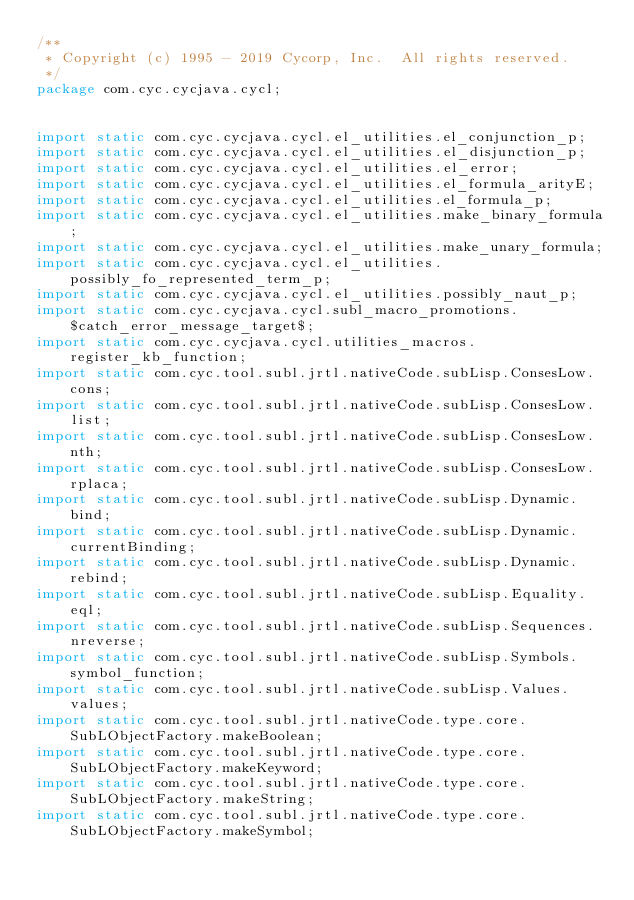<code> <loc_0><loc_0><loc_500><loc_500><_Java_>/**
 * Copyright (c) 1995 - 2019 Cycorp, Inc.  All rights reserved.
 */
package com.cyc.cycjava.cycl;


import static com.cyc.cycjava.cycl.el_utilities.el_conjunction_p;
import static com.cyc.cycjava.cycl.el_utilities.el_disjunction_p;
import static com.cyc.cycjava.cycl.el_utilities.el_error;
import static com.cyc.cycjava.cycl.el_utilities.el_formula_arityE;
import static com.cyc.cycjava.cycl.el_utilities.el_formula_p;
import static com.cyc.cycjava.cycl.el_utilities.make_binary_formula;
import static com.cyc.cycjava.cycl.el_utilities.make_unary_formula;
import static com.cyc.cycjava.cycl.el_utilities.possibly_fo_represented_term_p;
import static com.cyc.cycjava.cycl.el_utilities.possibly_naut_p;
import static com.cyc.cycjava.cycl.subl_macro_promotions.$catch_error_message_target$;
import static com.cyc.cycjava.cycl.utilities_macros.register_kb_function;
import static com.cyc.tool.subl.jrtl.nativeCode.subLisp.ConsesLow.cons;
import static com.cyc.tool.subl.jrtl.nativeCode.subLisp.ConsesLow.list;
import static com.cyc.tool.subl.jrtl.nativeCode.subLisp.ConsesLow.nth;
import static com.cyc.tool.subl.jrtl.nativeCode.subLisp.ConsesLow.rplaca;
import static com.cyc.tool.subl.jrtl.nativeCode.subLisp.Dynamic.bind;
import static com.cyc.tool.subl.jrtl.nativeCode.subLisp.Dynamic.currentBinding;
import static com.cyc.tool.subl.jrtl.nativeCode.subLisp.Dynamic.rebind;
import static com.cyc.tool.subl.jrtl.nativeCode.subLisp.Equality.eql;
import static com.cyc.tool.subl.jrtl.nativeCode.subLisp.Sequences.nreverse;
import static com.cyc.tool.subl.jrtl.nativeCode.subLisp.Symbols.symbol_function;
import static com.cyc.tool.subl.jrtl.nativeCode.subLisp.Values.values;
import static com.cyc.tool.subl.jrtl.nativeCode.type.core.SubLObjectFactory.makeBoolean;
import static com.cyc.tool.subl.jrtl.nativeCode.type.core.SubLObjectFactory.makeKeyword;
import static com.cyc.tool.subl.jrtl.nativeCode.type.core.SubLObjectFactory.makeString;
import static com.cyc.tool.subl.jrtl.nativeCode.type.core.SubLObjectFactory.makeSymbol;</code> 